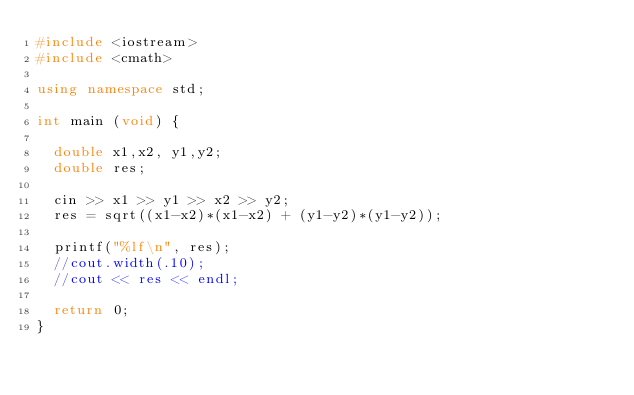Convert code to text. <code><loc_0><loc_0><loc_500><loc_500><_C++_>#include <iostream>
#include <cmath>

using namespace std;

int main (void) {

  double x1,x2, y1,y2;
  double res;
  
  cin >> x1 >> y1 >> x2 >> y2;
  res = sqrt((x1-x2)*(x1-x2) + (y1-y2)*(y1-y2));

  printf("%lf\n", res);
  //cout.width(.10);
  //cout << res << endl;
  
  return 0;
}</code> 